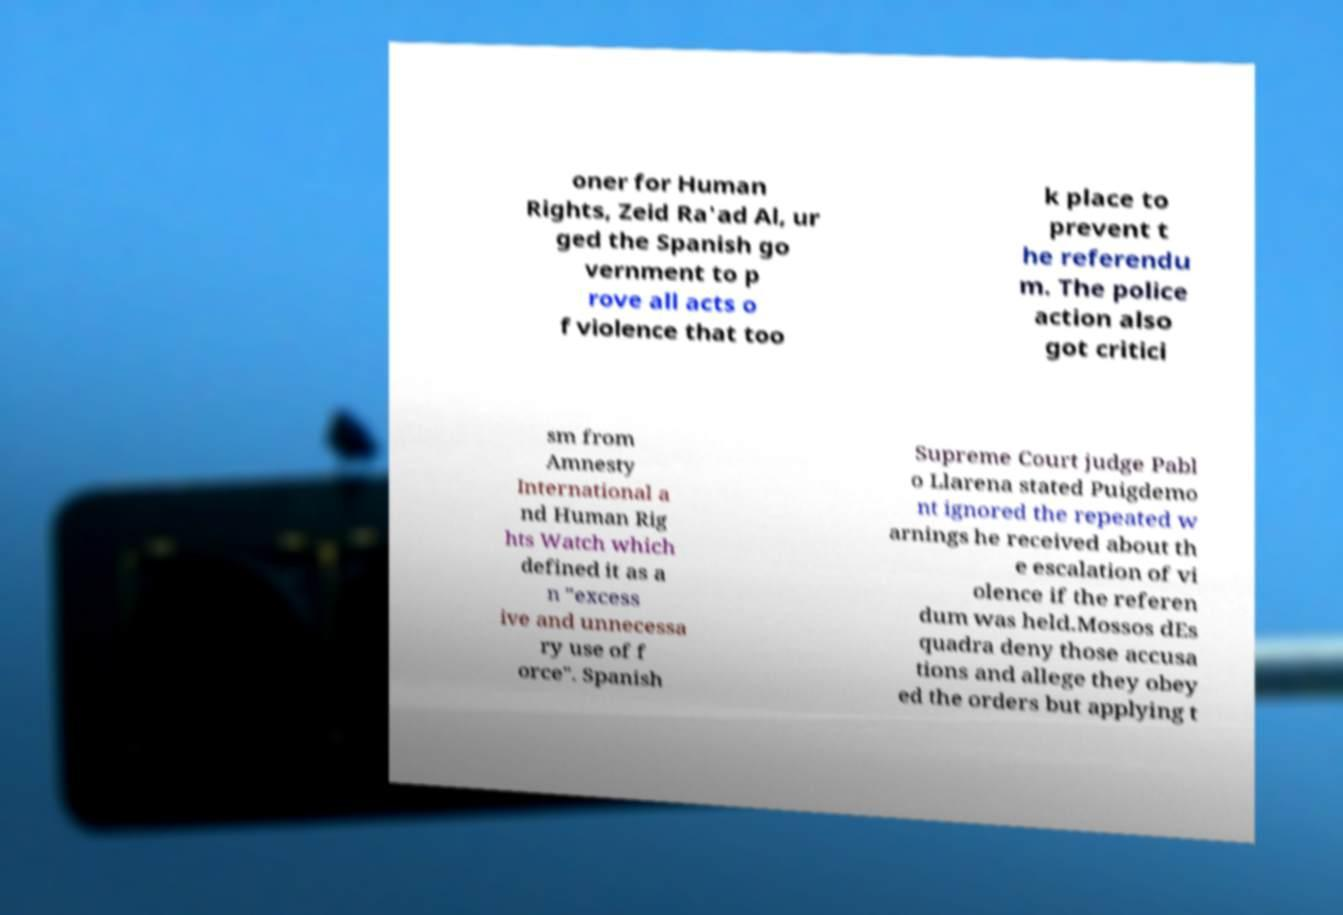For documentation purposes, I need the text within this image transcribed. Could you provide that? oner for Human Rights, Zeid Ra'ad Al, ur ged the Spanish go vernment to p rove all acts o f violence that too k place to prevent t he referendu m. The police action also got critici sm from Amnesty International a nd Human Rig hts Watch which defined it as a n "excess ive and unnecessa ry use of f orce". Spanish Supreme Court judge Pabl o Llarena stated Puigdemo nt ignored the repeated w arnings he received about th e escalation of vi olence if the referen dum was held.Mossos dEs quadra deny those accusa tions and allege they obey ed the orders but applying t 